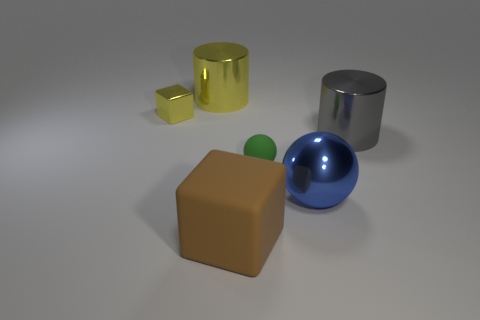There is a big thing that is the same color as the tiny metallic block; what shape is it?
Provide a succinct answer. Cylinder. There is a gray shiny thing; is its size the same as the matte block that is right of the tiny yellow metal cube?
Make the answer very short. Yes. There is a metallic thing right of the big blue metal thing that is on the right side of the small object that is on the right side of the large matte block; what size is it?
Give a very brief answer. Large. How many matte objects are either yellow blocks or big gray things?
Your response must be concise. 0. What color is the big metallic cylinder on the left side of the big brown rubber thing?
Provide a short and direct response. Yellow. There is a metallic object that is the same size as the rubber sphere; what shape is it?
Give a very brief answer. Cube. There is a tiny block; is it the same color as the metal object right of the big metal ball?
Your answer should be compact. No. How many things are either shiny cylinders on the right side of the big yellow cylinder or cylinders that are behind the small shiny object?
Offer a very short reply. 2. What material is the yellow cylinder that is the same size as the brown matte object?
Make the answer very short. Metal. What number of other objects are there of the same material as the small yellow thing?
Provide a succinct answer. 3. 